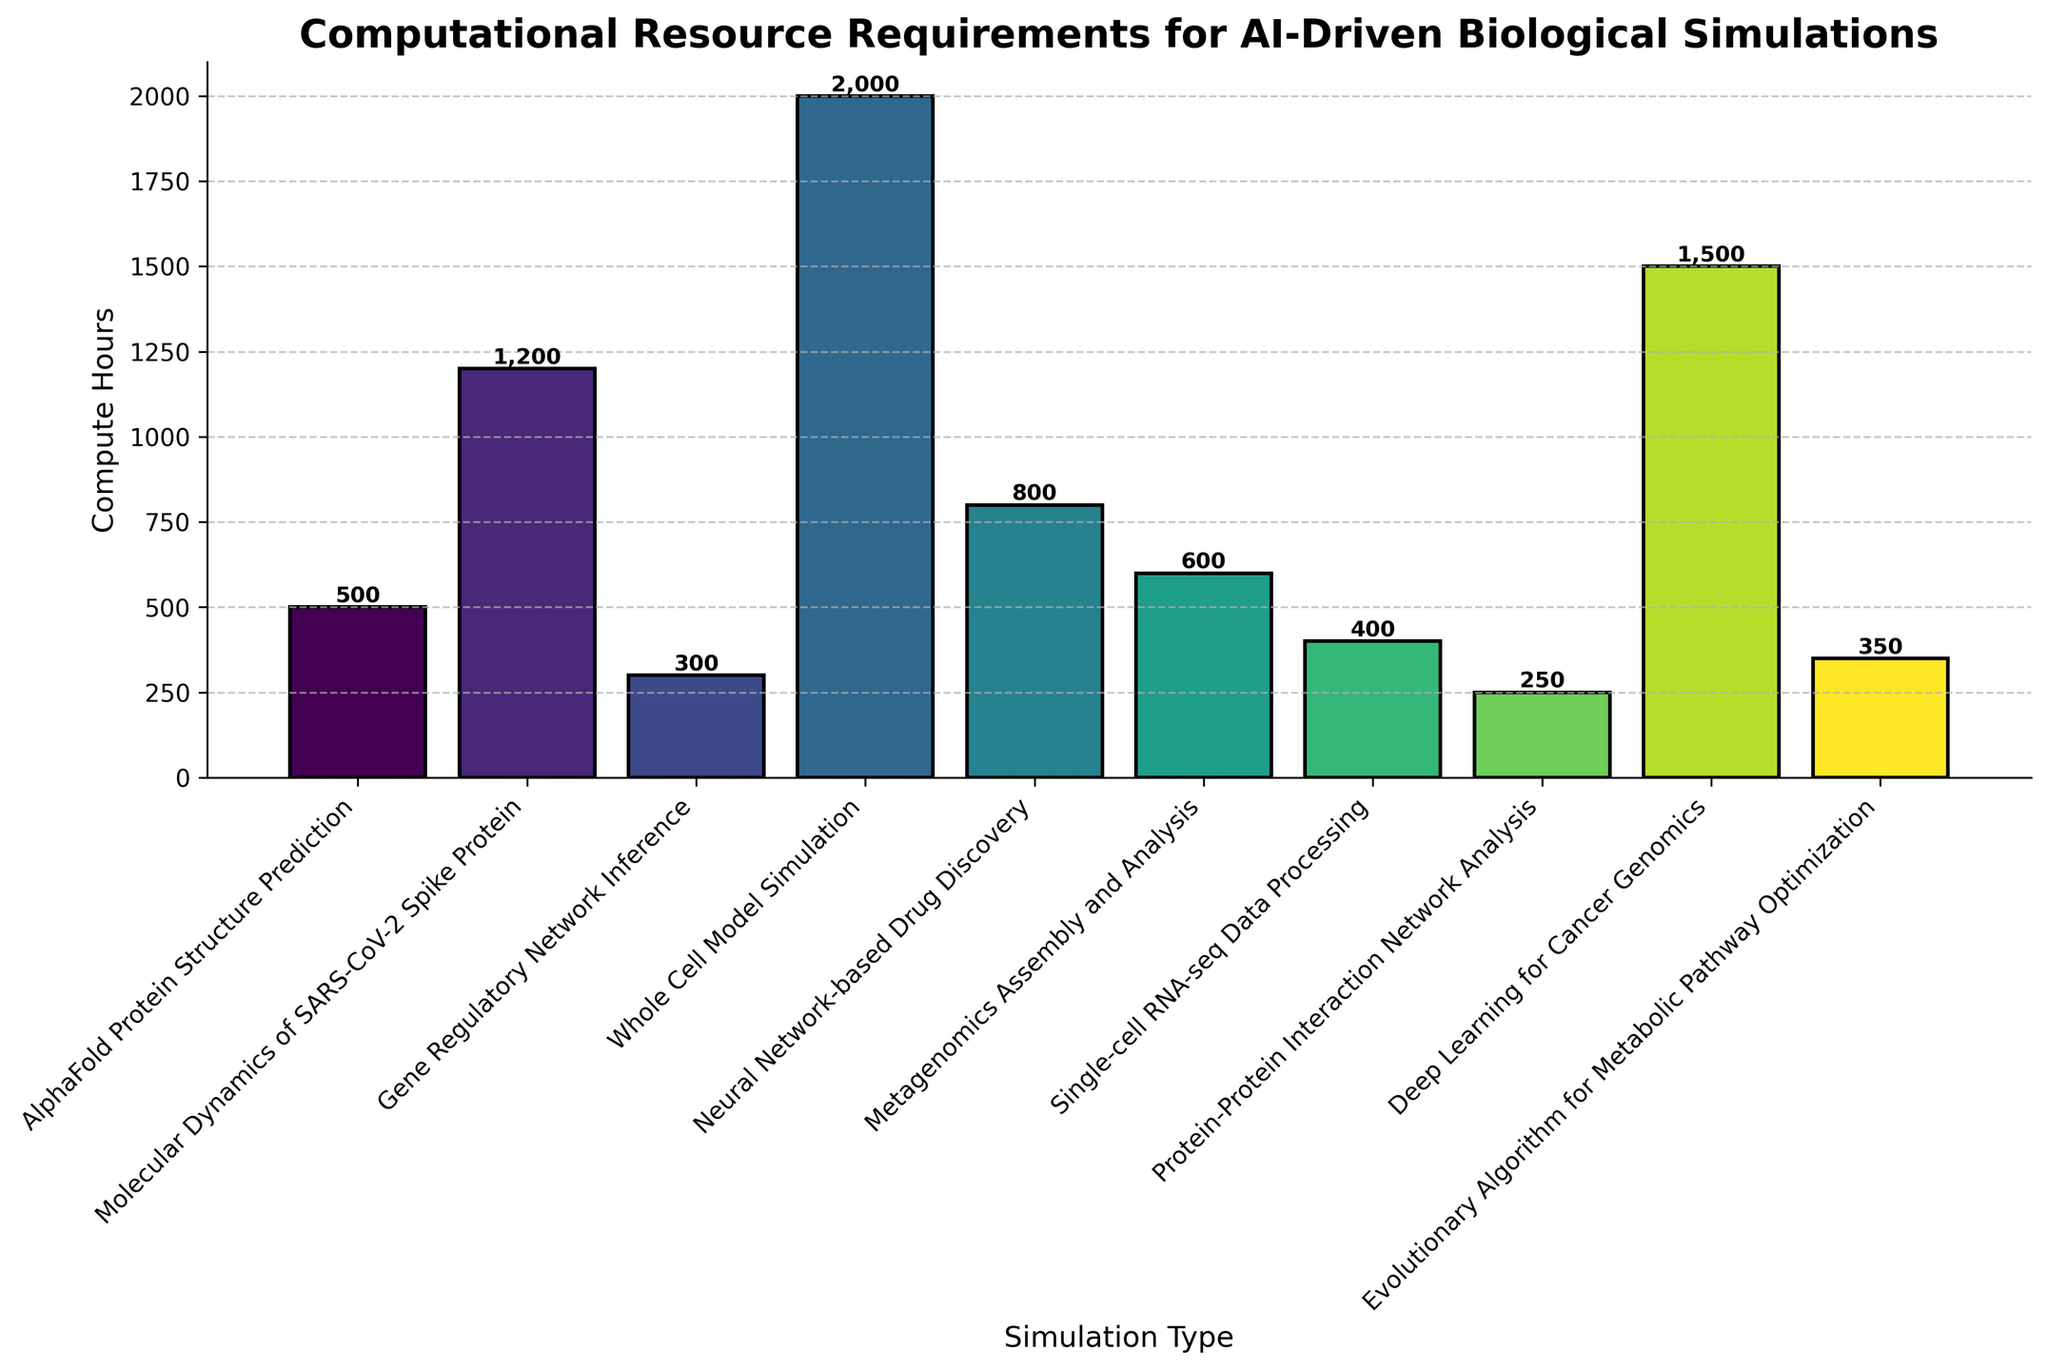What's the total computational resource requirement for all AI-driven biological simulations? Add up the compute hours for all simulations: 500 + 1200 + 300 + 2000 + 800 + 600 + 400 + 250 + 1500 + 350 = 7900 compute hours.
Answer: 7900 Which simulation requires the most computational resources? By comparing the height of all bars, the "Whole Cell Model Simulation" bar is the tallest, indicating it has the highest compute hours at 2000.
Answer: Whole Cell Model Simulation How much more compute hours does the "Deep Learning for Cancer Genomics" simulation require than the "AlphaFold Protein Structure Prediction" simulation? "Deep Learning for Cancer Genomics" requires 1500 compute hours and "AlphaFold Protein Structure Prediction" requires 500 compute hours. The difference is 1500 - 500 = 1000.
Answer: 1000 Which simulations require fewer compute hours than "Neural Network-based Drug Discovery"? "Neural Network-based Drug Discovery" requires 800 compute hours. The bars indicating fewer compute hours are: "AlphaFold Protein Structure Prediction" (500), "Gene Regulatory Network Inference" (300), "Single-cell RNA-seq Data Processing" (400), "Protein-Protein Interaction Network Analysis" (250), and "Evolutionary Algorithm for Metabolic Pathway Optimization" (350).
Answer: AlphaFold Protein Structure Prediction, Gene Regulatory Network Inference, Single-cell RNA-seq Data Processing, Protein-Protein Interaction Network Analysis, Evolutionary Algorithm for Metabolic Pathway Optimization What's the average computational resource requirement for the simulations that need more than 1000 compute hours? The simulations with more than 1000 compute hours are: "Molecular Dynamics of SARS-CoV-2 Spike Protein" (1200), "Whole Cell Model Simulation" (2000), and "Deep Learning for Cancer Genomics" (1500). The average is calculated as (1200 + 2000 + 1500) / 3 = 4700 / 3 ≈ 1567.
Answer: 1567 Which simulation has the shortest bar in the plot, and what does it represent? The shortest bar belongs to "Protein-Protein Interaction Network Analysis" with compute hours of 250.
Answer: Protein-Protein Interaction Network Analysis What's the relative difference in compute hours between "Metagenomics Assembly and Analysis" and "Single-cell RNA-seq Data Processing"? "Metagenomics Assembly and Analysis" has 600 compute hours and "Single-cell RNA-seq Data Processing" has 400 compute hours. The relative difference is calculated as (600 - 400) / 400 * 100 = 50%.
Answer: 50% What is the sum of compute hours for the simulations involving "Protein" in their names? The simulations are: "AlphaFold Protein Structure Prediction" (500), "Molecular Dynamics of SARS-CoV-2 Spike Protein" (1200), and "Protein-Protein Interaction Network Analysis" (250). The sum is 500 + 1200 + 250 = 1950 compute hours.
Answer: 1950 What is the ratio of compute hours between "Whole Cell Model Simulation" and "Gene Regulatory Network Inference"? The compute hours are 2000 for "Whole Cell Model Simulation" and 300 for "Gene Regulatory Network Inference". The ratio is 2000 / 300 ≈ 6.67.
Answer: 6.67 